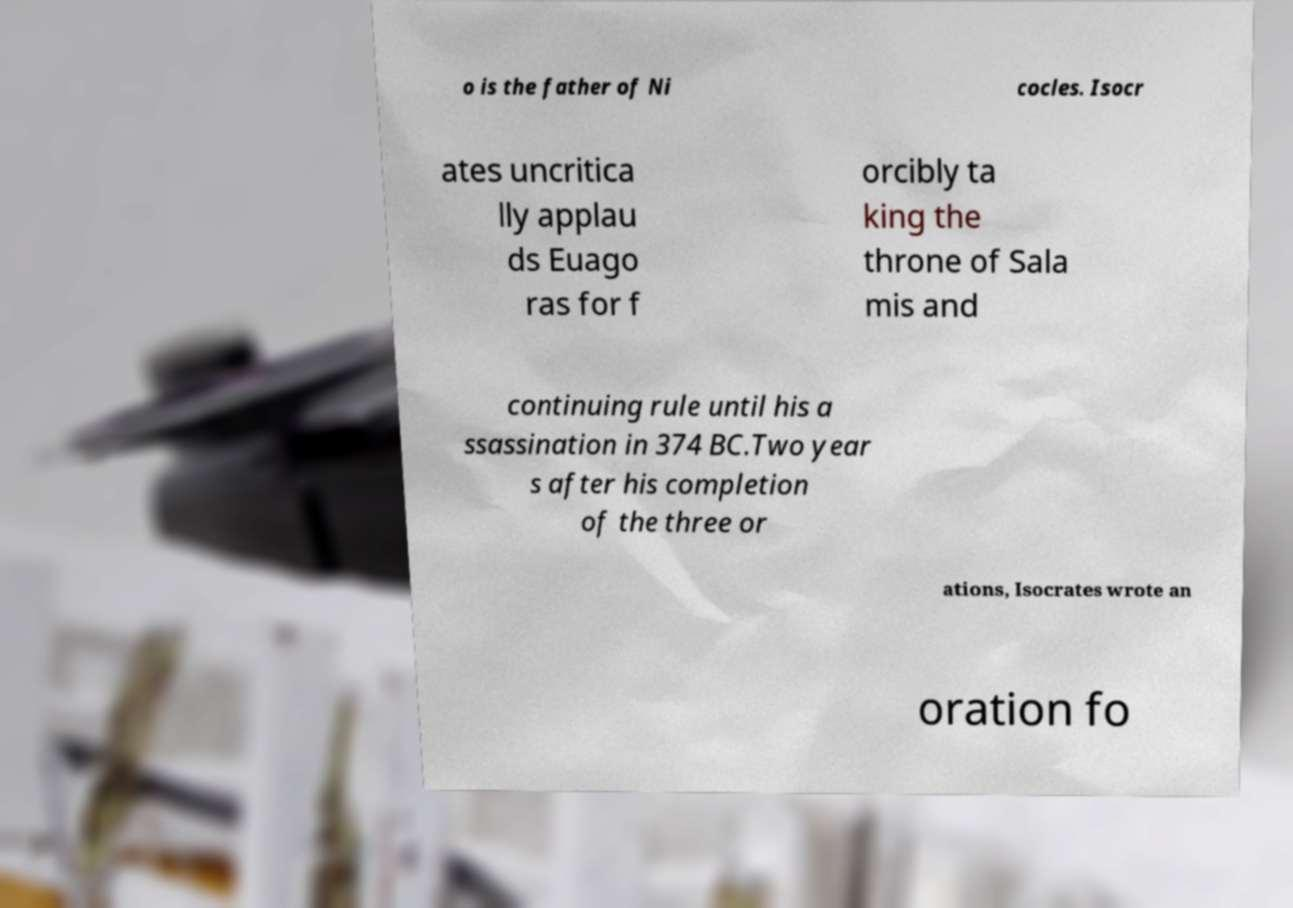What messages or text are displayed in this image? I need them in a readable, typed format. o is the father of Ni cocles. Isocr ates uncritica lly applau ds Euago ras for f orcibly ta king the throne of Sala mis and continuing rule until his a ssassination in 374 BC.Two year s after his completion of the three or ations, Isocrates wrote an oration fo 